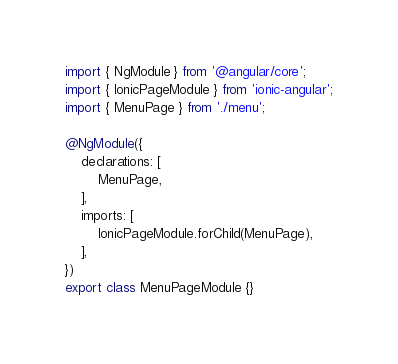Convert code to text. <code><loc_0><loc_0><loc_500><loc_500><_TypeScript_>import { NgModule } from '@angular/core';
import { IonicPageModule } from 'ionic-angular';
import { MenuPage } from './menu';

@NgModule({
	declarations: [
		MenuPage,
	],
	imports: [
		IonicPageModule.forChild(MenuPage),
	],
})
export class MenuPageModule {}
</code> 